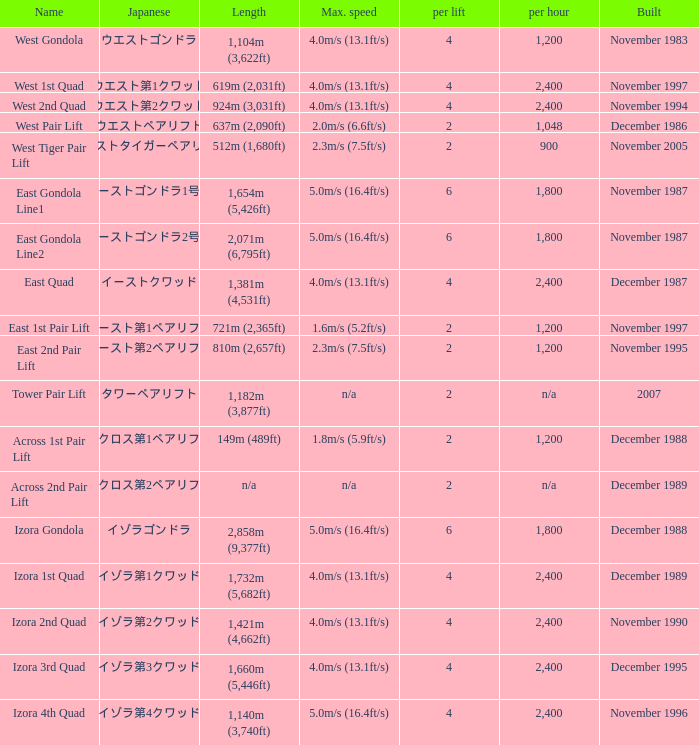How heavy is the  maximum 6.0. 